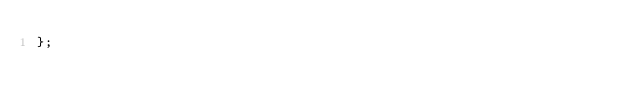Convert code to text. <code><loc_0><loc_0><loc_500><loc_500><_Haxe_>};
</code> 